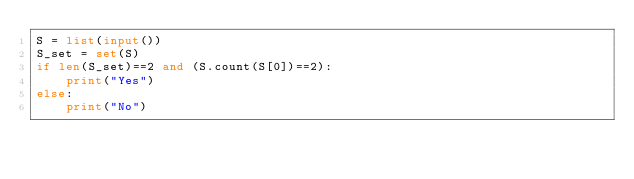Convert code to text. <code><loc_0><loc_0><loc_500><loc_500><_Python_>S = list(input())
S_set = set(S)
if len(S_set)==2 and (S.count(S[0])==2):
    print("Yes")
else:
    print("No")</code> 